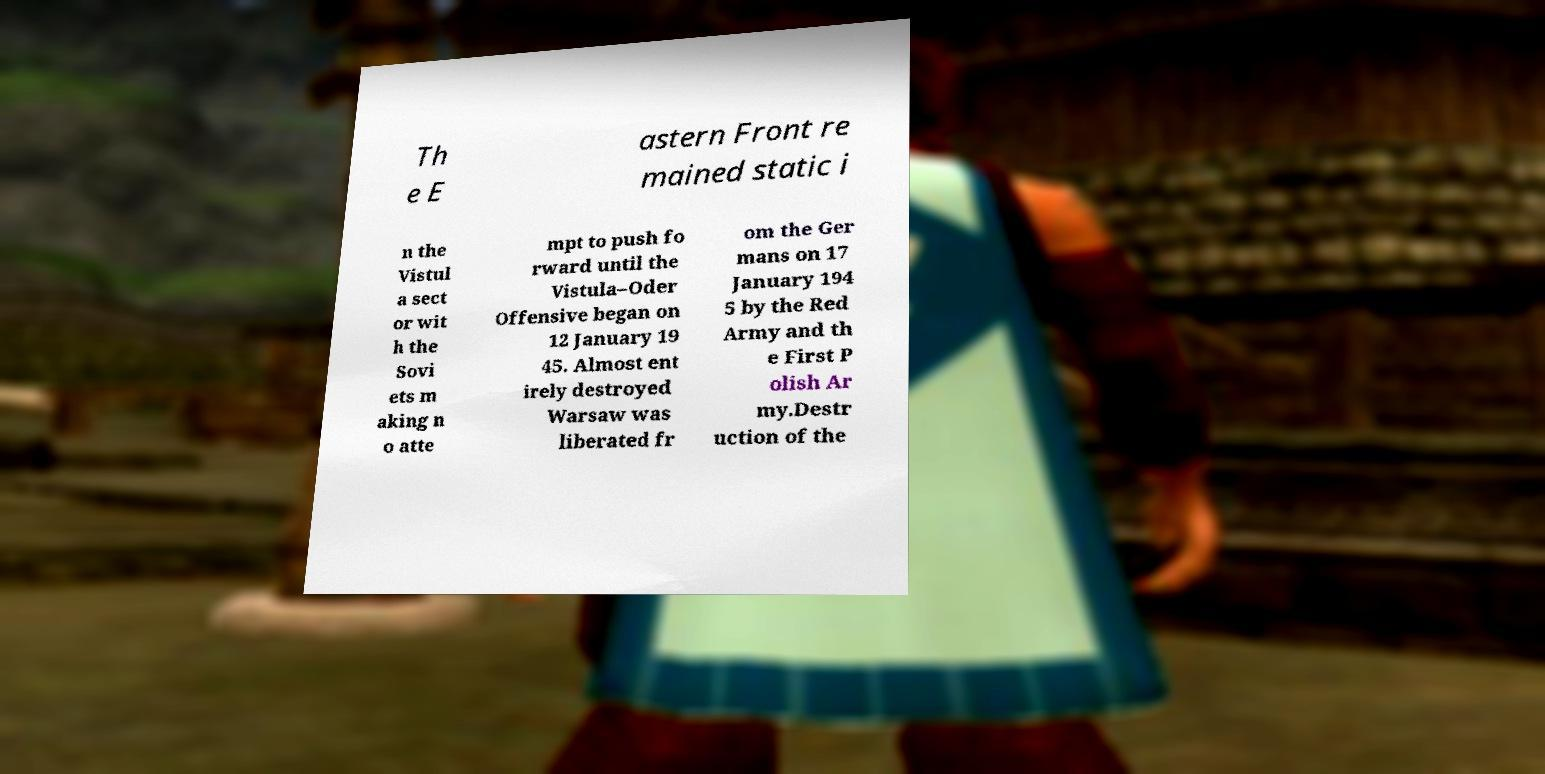I need the written content from this picture converted into text. Can you do that? Th e E astern Front re mained static i n the Vistul a sect or wit h the Sovi ets m aking n o atte mpt to push fo rward until the Vistula–Oder Offensive began on 12 January 19 45. Almost ent irely destroyed Warsaw was liberated fr om the Ger mans on 17 January 194 5 by the Red Army and th e First P olish Ar my.Destr uction of the 